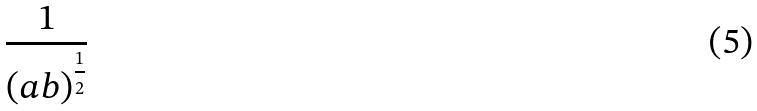Convert formula to latex. <formula><loc_0><loc_0><loc_500><loc_500>\frac { 1 } { ( a b ) ^ { \frac { 1 } { 2 } } }</formula> 